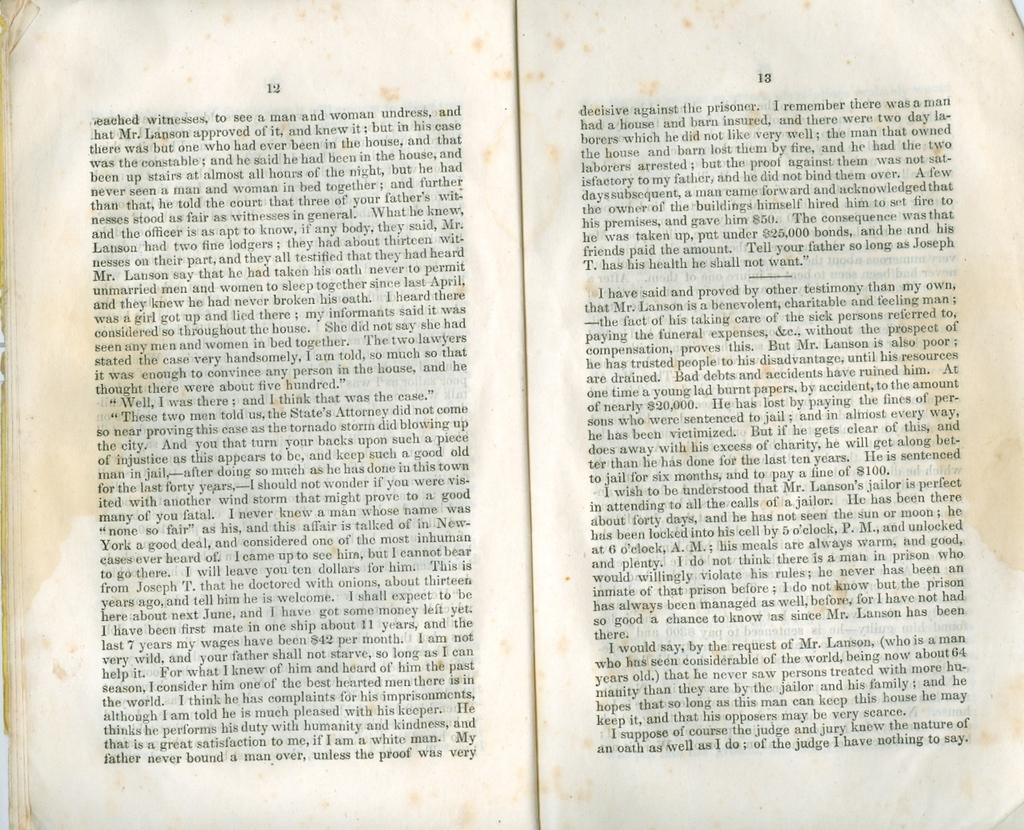What page is the book on?
Give a very brief answer. 12. 